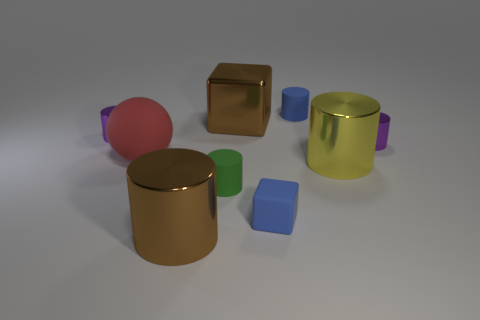Subtract all green rubber cylinders. How many cylinders are left? 5 Subtract all red balls. How many purple cylinders are left? 2 Subtract all blue cubes. How many cubes are left? 1 Subtract all spheres. How many objects are left? 8 Subtract all purple balls. Subtract all blue cylinders. How many balls are left? 1 Subtract all rubber cubes. Subtract all tiny purple metal cubes. How many objects are left? 8 Add 8 large rubber things. How many large rubber things are left? 9 Add 9 large blocks. How many large blocks exist? 10 Subtract 0 cyan cubes. How many objects are left? 9 Subtract 1 blocks. How many blocks are left? 1 